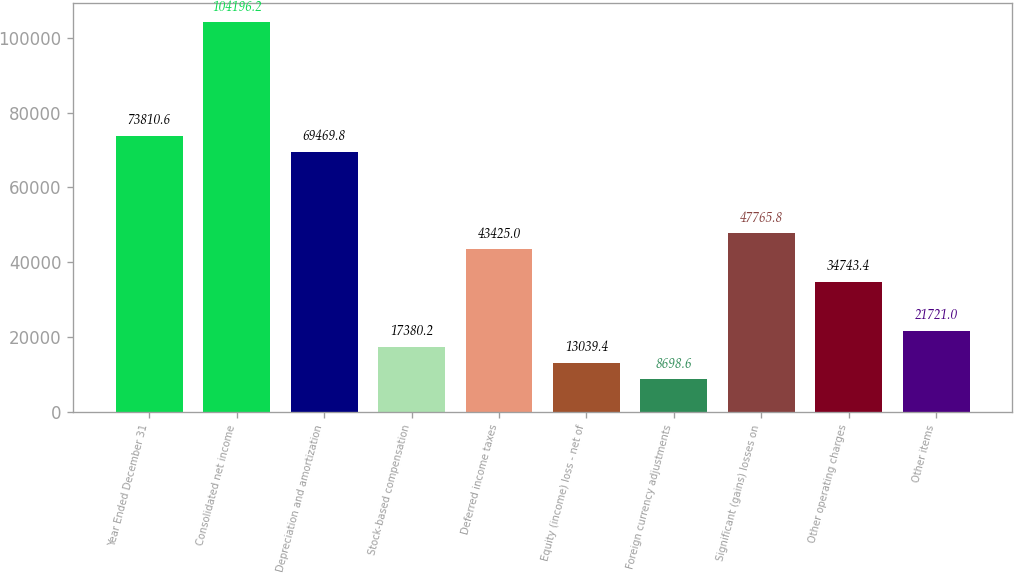Convert chart to OTSL. <chart><loc_0><loc_0><loc_500><loc_500><bar_chart><fcel>Year Ended December 31<fcel>Consolidated net income<fcel>Depreciation and amortization<fcel>Stock-based compensation<fcel>Deferred income taxes<fcel>Equity (income) loss - net of<fcel>Foreign currency adjustments<fcel>Significant (gains) losses on<fcel>Other operating charges<fcel>Other items<nl><fcel>73810.6<fcel>104196<fcel>69469.8<fcel>17380.2<fcel>43425<fcel>13039.4<fcel>8698.6<fcel>47765.8<fcel>34743.4<fcel>21721<nl></chart> 